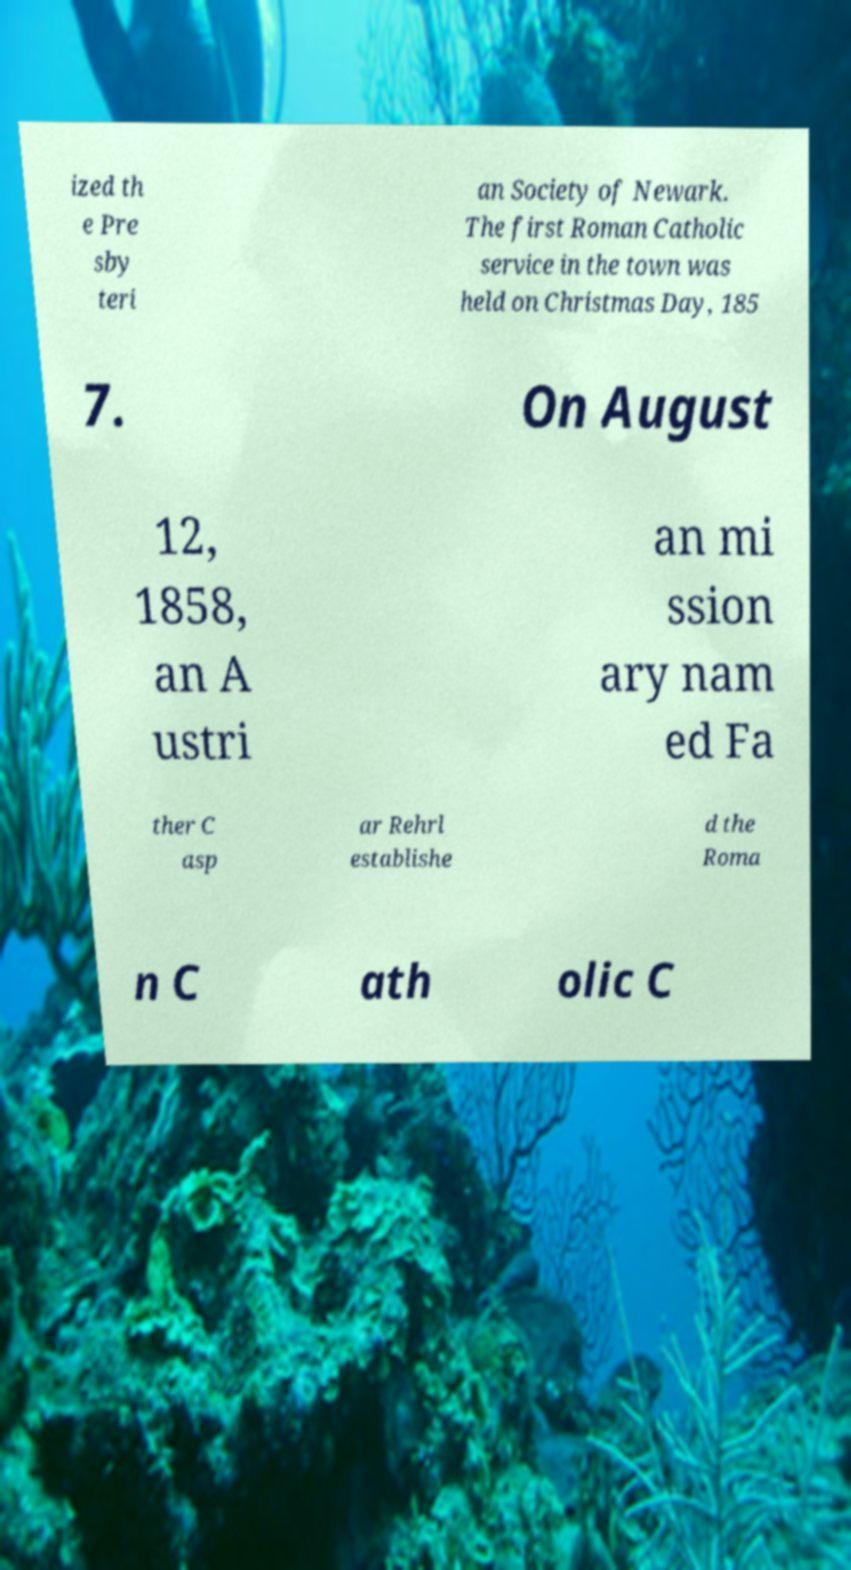Can you accurately transcribe the text from the provided image for me? ized th e Pre sby teri an Society of Newark. The first Roman Catholic service in the town was held on Christmas Day, 185 7. On August 12, 1858, an A ustri an mi ssion ary nam ed Fa ther C asp ar Rehrl establishe d the Roma n C ath olic C 